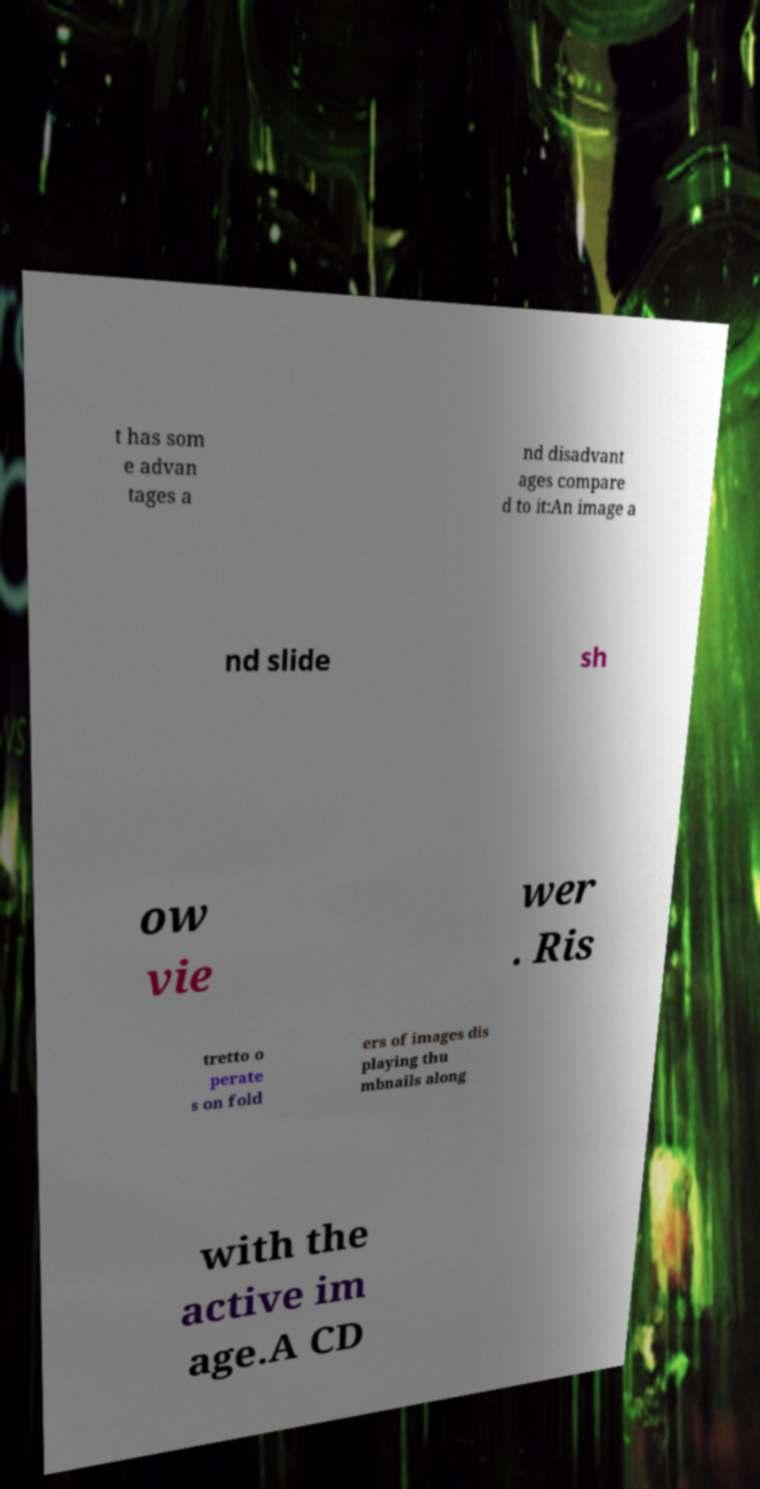Could you extract and type out the text from this image? t has som e advan tages a nd disadvant ages compare d to it:An image a nd slide sh ow vie wer . Ris tretto o perate s on fold ers of images dis playing thu mbnails along with the active im age.A CD 